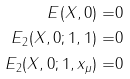Convert formula to latex. <formula><loc_0><loc_0><loc_500><loc_500>E ( X , 0 ) = & 0 \\ E _ { 2 } ( X , 0 ; 1 , 1 ) = & 0 \\ E _ { 2 } ( X , 0 ; 1 , x _ { \mu } ) = & 0 \\</formula> 